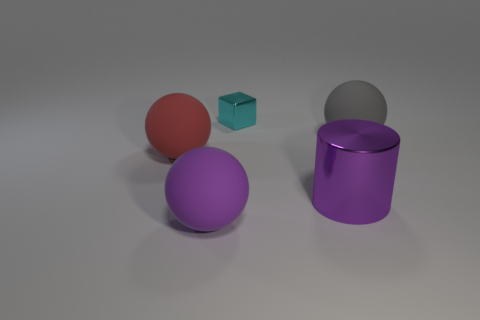How do the shadows in the image inform us about the lighting? The shadows in the image are cast to the bottom and slightly to the right of each object, indicating that the light source is positioned to the top-left. The soft edges of the shadows suggest that the lighting is diffuse, which creates a gentle contrast across the scene. 